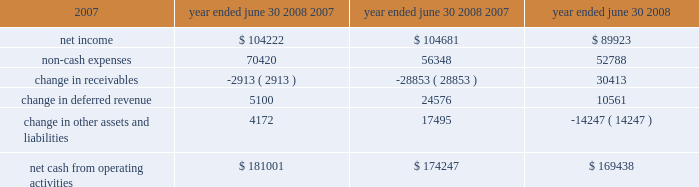L iquidity and capital resources we have historically generated positive cash flow from operations and have generally used funds generated from operations and short-term borrowings on our revolving credit facility to meet capital requirements .
We expect this trend to continue in the future .
The company's cash and cash equivalents decreased to $ 65565 at june 30 , 2008 from $ 88617 at june 30 , 2007 .
The table summarizes net cash from operating activities in the statement of cash flows : year ended june 30 cash provided by operations increased $ 6754 to $ 181001 for the fiscal year ended june 30 , 2008 as compared to $ 174247 for the fiscal year ended june 30 , 2007 .
This increase is primarily attributable to an increase in expenses that do not have a corresponding cash outflow , such as depreciation and amortization , as a percentage of total net income .
Cash used in investing activities for the fiscal year ended june 2008 was $ 102148 and includes payments for acquisitions of $ 48109 , plus $ 1215 in contingent consideration paid on prior years 2019 acquisitions .
During fiscal 2007 , payments for acquisitions totaled $ 34006 , plus $ 5301 paid on earn-outs and other acquisition adjustments .
Capital expenditures for fiscal 2008 were $ 31105 compared to $ 34202 for fiscal 2007 .
Cash used for software development in fiscal 2008 was $ 23736 compared to $ 20743 during the prior year .
Net cash used in financing activities for the current fiscal year was $ 101905 and includes the repurchase of 4200 shares of our common stock for $ 100996 , the payment of dividends of $ 24683 and $ 429 net repayment on our revolving credit facilities .
Cash used in financing activities was partially offset by proceeds of $ 20394 from the exercise of stock options and the sale of common stock and $ 3809 excess tax benefits from stock option exercises .
During fiscal 2007 , net cash used in financing activities included the repurchase of our common stock for $ 98413 and the payment of dividends of $ 21685 .
As in the current year , cash used in fiscal 2007 was partially offset by proceeds from the exercise of stock options and the sale of common stock of $ 29212 , $ 4640 excess tax benefits from stock option exercises and $ 19388 net borrowings on revolving credit facilities .
At june 30 , 2008 , the company had negative working capital of $ 11418 ; however , the largest component of current liabilities was deferred revenue of $ 212375 .
The cash outlay necessary to provide the services related to these deferred revenues is significantly less than this recorded balance .
Therefore , we do not anticipate any liquidity problems to result from this condition .
U.s .
Financial markets and many of the largest u.s .
Financial institutions have recently been shaken by negative developments in the home mortgage industry and the mortgage markets , and particularly the markets for subprime mortgage-backed securities .
While we believe it is too early to predict what effect , if any , these developments may have , we have not experienced any significant issues with our current collec- tion efforts , and we believe that any future impact to our liquidity would be minimized by our access to available lines of credit .
2008 2007 2006 .

During fiscal 2007 , was the net cash used in financing activities included the repurchase of our common stock greater than cash for payment of dividends? 
Computations: (98413 > 21685)
Answer: yes. 